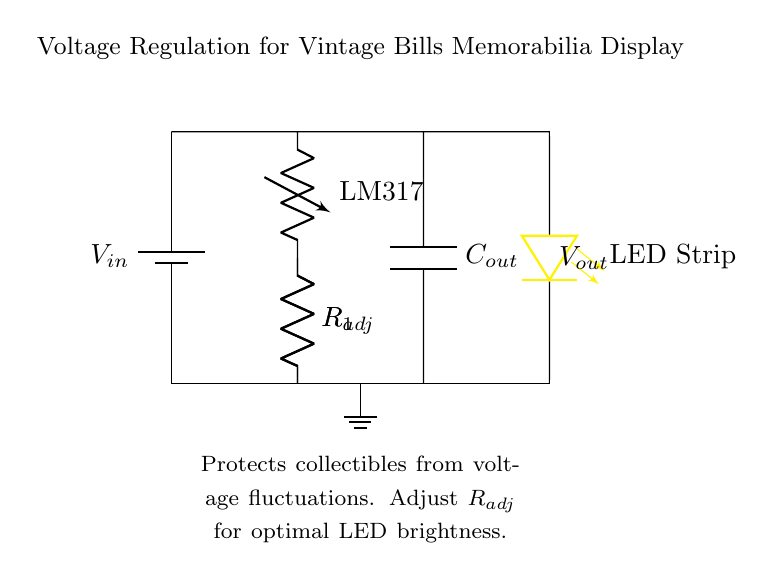What is the input voltage source labeled as? The input voltage source is labeled as \( V_{in} \) in the diagram, indicating the supplied voltage that powers the circuit.
Answer: V in What type of regulator is used in this circuit? The diagram indicates that an LM317 voltage regulator is used for providing a stable output voltage, making it clear it's a three-terminal adjustable voltage regulator.
Answer: LM317 What component is used to enhance LED brightness control? The \( R_{adj} \) resistor is connected to the voltage regulator, allowing for adjustment of the output voltage, which impacts the brightness of the connected LED strip.
Answer: R adj How many resistors are present in the circuit? There are two resistors in the circuit: \( R_1 \) and \( R_{adj} \). Counting them from the diagram confirms their presence in the voltage regulator setup.
Answer: 2 What is the purpose of the output capacitor? The \( C_{out} \) capacitor stabilizes the output voltage by filtering out any voltage spikes or fluctuations, providing smooth power to the LED strip.
Answer: Stabilization What does the diode strip represent in the circuit? The LED strip signifies the load of the voltage regulation circuit, which lights up when powered correctly by the regulated voltage from the LM317.
Answer: Load What does adjusting \( R_{adj} \) do to the circuit? Adjusting \( R_{adj} \) alters the resistance, which changes the output voltage, thereby influencing the brightness of the LED strip connected to the circuit.
Answer: Changes brightness 